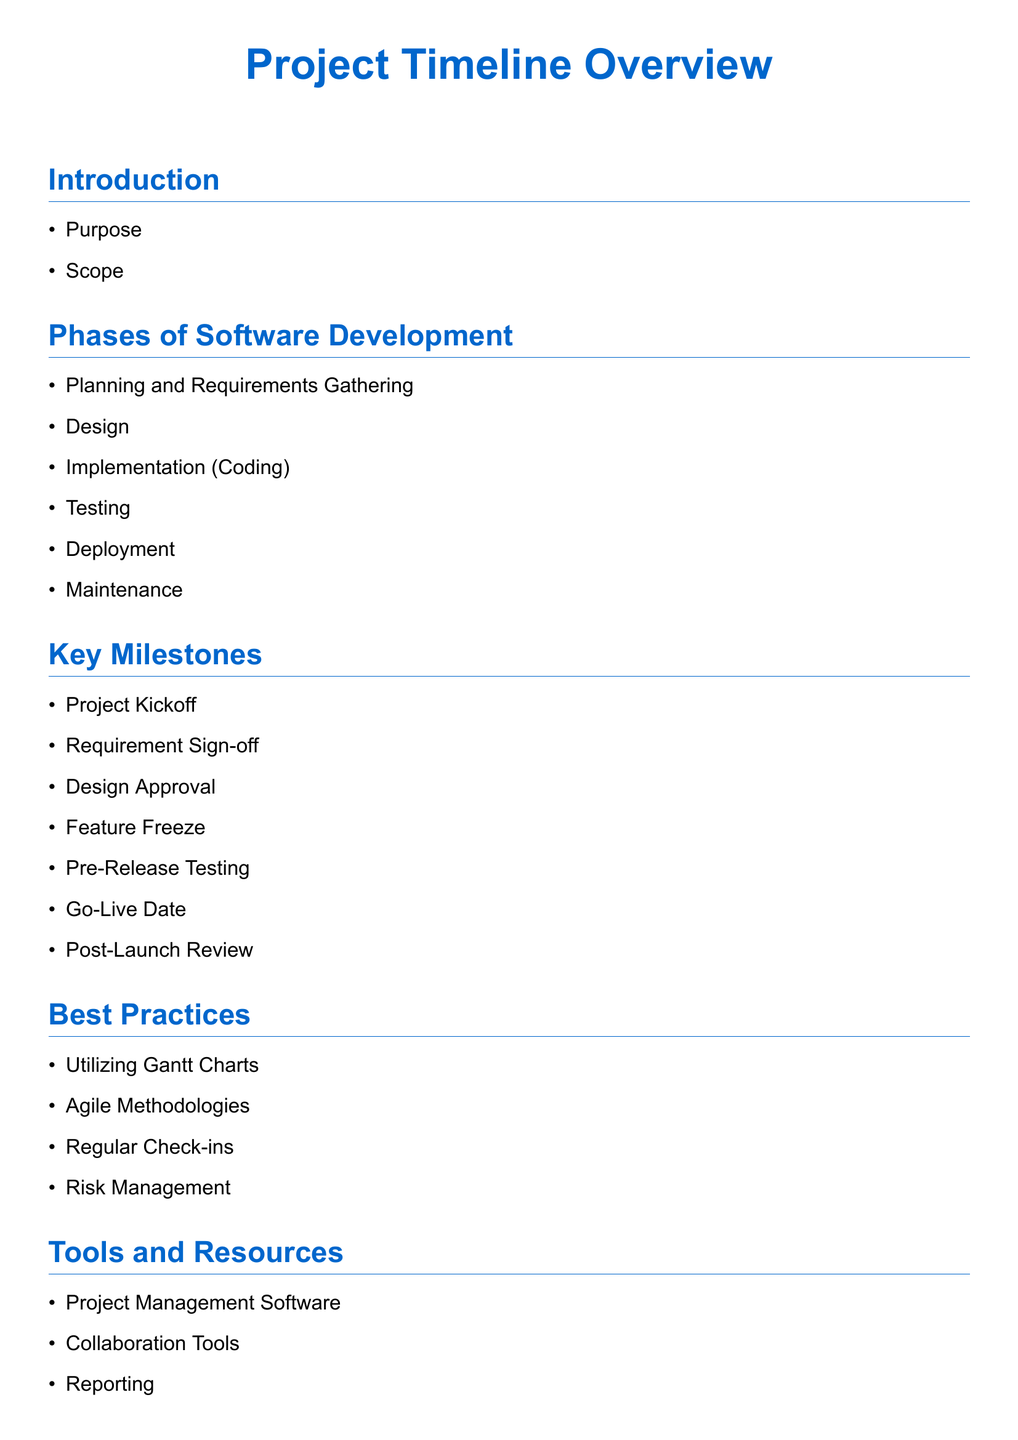What is the purpose of the document? The document outlines the timeline of a software development project, including phases and milestones.
Answer: Project Timeline Overview What is the first phase of software development mentioned? The first phase listed under Phases of Software Development.
Answer: Planning and Requirements Gathering What is the key milestone immediately following Requirement Sign-off? It's the next item listed after Requirement Sign-off in Key Milestones.
Answer: Design Approval Which best practice involves visual project management? This practice is designed to help in tracking project timelines visually.
Answer: Utilizing Gantt Charts What type of software is mentioned as a tool for managing projects? This refers to tools used to oversee project progress.
Answer: Project Management Software What phase occurs right after Implementation? Identify the phase listed directly following Implementation in the document.
Answer: Testing How many key milestones are listed in the document? This is the total count of items in the Key Milestones section.
Answer: Seven What is suggested for regular project team engagements? This is a common method to ensure project alignment.
Answer: Regular Check-ins What is the last point mentioned in the Conclusion section? This is the final item included in the Conclusion section.
Answer: Future Considerations 